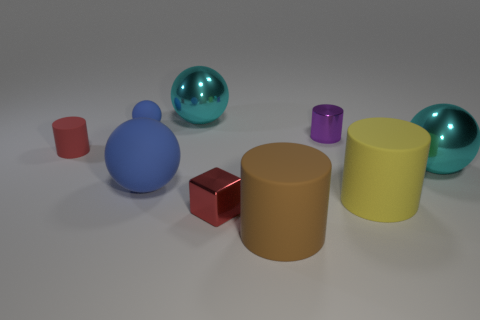The ball that is the same size as the metal cylinder is what color?
Make the answer very short. Blue. There is a large object that is both in front of the tiny red matte thing and on the left side of the large brown matte thing; what shape is it?
Give a very brief answer. Sphere. How big is the cylinder that is left of the matte object behind the purple shiny cylinder?
Provide a short and direct response. Small. How many small cylinders have the same color as the small shiny cube?
Offer a terse response. 1. How many other things are there of the same size as the block?
Offer a terse response. 3. There is a ball that is behind the small red rubber thing and to the right of the tiny blue matte object; how big is it?
Provide a short and direct response. Large. What number of metallic things are the same shape as the yellow rubber thing?
Your response must be concise. 1. What is the purple object made of?
Ensure brevity in your answer.  Metal. Is the shape of the big yellow thing the same as the small blue object?
Offer a terse response. No. Is there a small yellow cube that has the same material as the big blue object?
Give a very brief answer. No. 